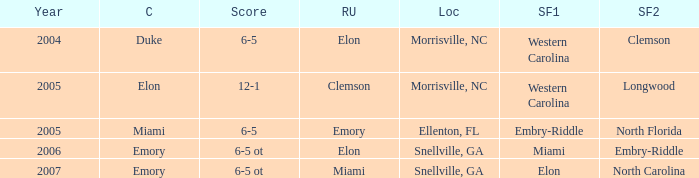Which team was the second semi finalist in 2007? North Carolina. 